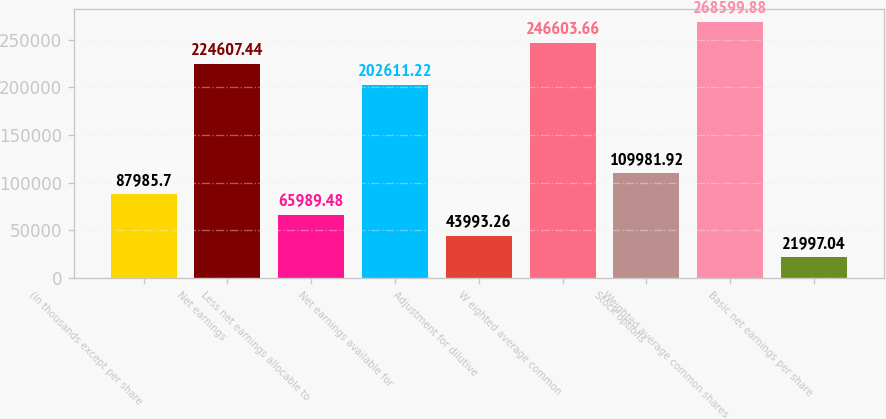Convert chart. <chart><loc_0><loc_0><loc_500><loc_500><bar_chart><fcel>(In thousands except per share<fcel>Net earnings<fcel>Less net earnings allocable to<fcel>Net earnings available for<fcel>Adjustment for dilutive<fcel>W eighted average common<fcel>Stock options<fcel>Weighted average common shares<fcel>Basic net earnings per share<nl><fcel>87985.7<fcel>224607<fcel>65989.5<fcel>202611<fcel>43993.3<fcel>246604<fcel>109982<fcel>268600<fcel>21997<nl></chart> 